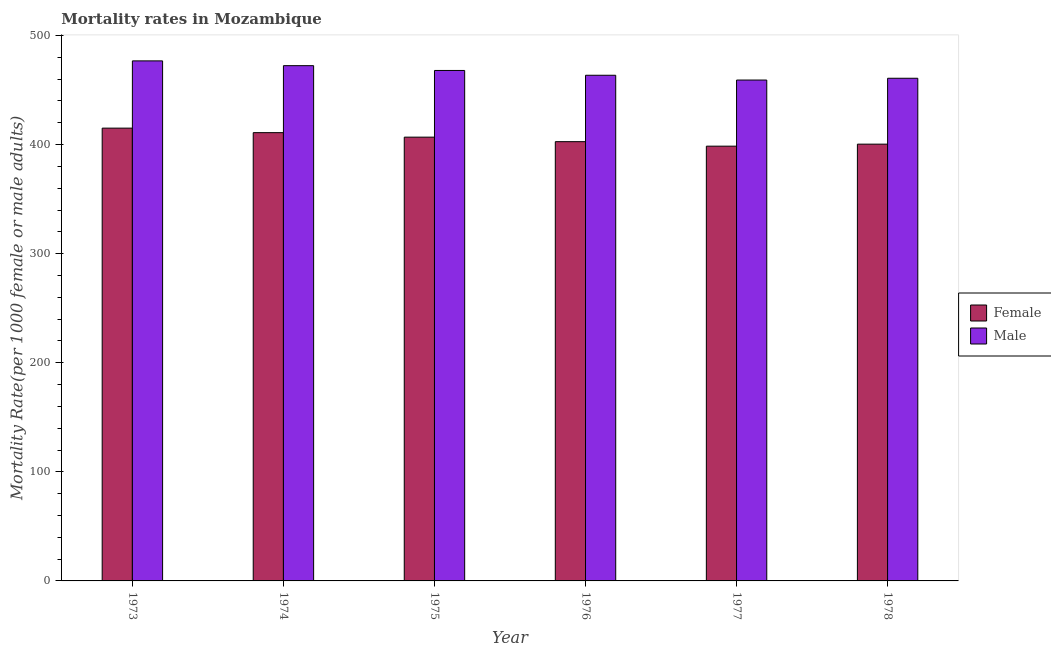How many different coloured bars are there?
Your response must be concise. 2. Are the number of bars per tick equal to the number of legend labels?
Provide a short and direct response. Yes. Are the number of bars on each tick of the X-axis equal?
Keep it short and to the point. Yes. How many bars are there on the 1st tick from the left?
Ensure brevity in your answer.  2. What is the label of the 3rd group of bars from the left?
Your answer should be very brief. 1975. In how many cases, is the number of bars for a given year not equal to the number of legend labels?
Offer a very short reply. 0. What is the female mortality rate in 1976?
Your answer should be very brief. 402.69. Across all years, what is the maximum male mortality rate?
Offer a very short reply. 476.75. Across all years, what is the minimum female mortality rate?
Give a very brief answer. 398.56. In which year was the male mortality rate maximum?
Provide a short and direct response. 1973. What is the total male mortality rate in the graph?
Provide a succinct answer. 2800.63. What is the difference between the male mortality rate in 1973 and that in 1975?
Provide a succinct answer. 8.79. What is the difference between the male mortality rate in 1977 and the female mortality rate in 1974?
Provide a short and direct response. -13.18. What is the average male mortality rate per year?
Give a very brief answer. 466.77. In the year 1973, what is the difference between the female mortality rate and male mortality rate?
Ensure brevity in your answer.  0. What is the ratio of the female mortality rate in 1974 to that in 1977?
Your answer should be very brief. 1.03. Is the male mortality rate in 1974 less than that in 1977?
Offer a very short reply. No. What is the difference between the highest and the second highest female mortality rate?
Your response must be concise. 4.13. What is the difference between the highest and the lowest female mortality rate?
Keep it short and to the point. 16.53. Is the sum of the male mortality rate in 1976 and 1978 greater than the maximum female mortality rate across all years?
Offer a very short reply. Yes. What does the 1st bar from the right in 1975 represents?
Make the answer very short. Male. How many bars are there?
Give a very brief answer. 12. Are all the bars in the graph horizontal?
Give a very brief answer. No. How many years are there in the graph?
Offer a terse response. 6. What is the difference between two consecutive major ticks on the Y-axis?
Make the answer very short. 100. Does the graph contain any zero values?
Keep it short and to the point. No. How are the legend labels stacked?
Make the answer very short. Vertical. What is the title of the graph?
Provide a short and direct response. Mortality rates in Mozambique. What is the label or title of the X-axis?
Offer a terse response. Year. What is the label or title of the Y-axis?
Make the answer very short. Mortality Rate(per 1000 female or male adults). What is the Mortality Rate(per 1000 female or male adults) in Female in 1973?
Your answer should be very brief. 415.09. What is the Mortality Rate(per 1000 female or male adults) in Male in 1973?
Give a very brief answer. 476.75. What is the Mortality Rate(per 1000 female or male adults) in Female in 1974?
Give a very brief answer. 410.96. What is the Mortality Rate(per 1000 female or male adults) in Male in 1974?
Keep it short and to the point. 472.36. What is the Mortality Rate(per 1000 female or male adults) of Female in 1975?
Your response must be concise. 406.82. What is the Mortality Rate(per 1000 female or male adults) in Male in 1975?
Make the answer very short. 467.96. What is the Mortality Rate(per 1000 female or male adults) of Female in 1976?
Ensure brevity in your answer.  402.69. What is the Mortality Rate(per 1000 female or male adults) in Male in 1976?
Offer a very short reply. 463.57. What is the Mortality Rate(per 1000 female or male adults) in Female in 1977?
Your answer should be compact. 398.56. What is the Mortality Rate(per 1000 female or male adults) in Male in 1977?
Give a very brief answer. 459.18. What is the Mortality Rate(per 1000 female or male adults) in Female in 1978?
Give a very brief answer. 400.41. What is the Mortality Rate(per 1000 female or male adults) in Male in 1978?
Offer a terse response. 460.81. Across all years, what is the maximum Mortality Rate(per 1000 female or male adults) of Female?
Ensure brevity in your answer.  415.09. Across all years, what is the maximum Mortality Rate(per 1000 female or male adults) of Male?
Offer a terse response. 476.75. Across all years, what is the minimum Mortality Rate(per 1000 female or male adults) in Female?
Provide a short and direct response. 398.56. Across all years, what is the minimum Mortality Rate(per 1000 female or male adults) in Male?
Provide a short and direct response. 459.18. What is the total Mortality Rate(per 1000 female or male adults) of Female in the graph?
Keep it short and to the point. 2434.53. What is the total Mortality Rate(per 1000 female or male adults) in Male in the graph?
Provide a short and direct response. 2800.63. What is the difference between the Mortality Rate(per 1000 female or male adults) of Female in 1973 and that in 1974?
Give a very brief answer. 4.13. What is the difference between the Mortality Rate(per 1000 female or male adults) in Male in 1973 and that in 1974?
Give a very brief answer. 4.39. What is the difference between the Mortality Rate(per 1000 female or male adults) of Female in 1973 and that in 1975?
Ensure brevity in your answer.  8.27. What is the difference between the Mortality Rate(per 1000 female or male adults) of Male in 1973 and that in 1975?
Offer a very short reply. 8.79. What is the difference between the Mortality Rate(per 1000 female or male adults) of Female in 1973 and that in 1976?
Provide a short and direct response. 12.4. What is the difference between the Mortality Rate(per 1000 female or male adults) of Male in 1973 and that in 1976?
Provide a succinct answer. 13.18. What is the difference between the Mortality Rate(per 1000 female or male adults) in Female in 1973 and that in 1977?
Offer a very short reply. 16.53. What is the difference between the Mortality Rate(per 1000 female or male adults) of Male in 1973 and that in 1977?
Offer a terse response. 17.57. What is the difference between the Mortality Rate(per 1000 female or male adults) of Female in 1973 and that in 1978?
Provide a short and direct response. 14.68. What is the difference between the Mortality Rate(per 1000 female or male adults) of Male in 1973 and that in 1978?
Offer a terse response. 15.94. What is the difference between the Mortality Rate(per 1000 female or male adults) of Female in 1974 and that in 1975?
Offer a very short reply. 4.13. What is the difference between the Mortality Rate(per 1000 female or male adults) in Male in 1974 and that in 1975?
Your answer should be very brief. 4.39. What is the difference between the Mortality Rate(per 1000 female or male adults) in Female in 1974 and that in 1976?
Provide a succinct answer. 8.27. What is the difference between the Mortality Rate(per 1000 female or male adults) in Male in 1974 and that in 1976?
Your response must be concise. 8.79. What is the difference between the Mortality Rate(per 1000 female or male adults) of Female in 1974 and that in 1977?
Offer a very short reply. 12.4. What is the difference between the Mortality Rate(per 1000 female or male adults) in Male in 1974 and that in 1977?
Keep it short and to the point. 13.18. What is the difference between the Mortality Rate(per 1000 female or male adults) in Female in 1974 and that in 1978?
Ensure brevity in your answer.  10.54. What is the difference between the Mortality Rate(per 1000 female or male adults) of Male in 1974 and that in 1978?
Offer a very short reply. 11.54. What is the difference between the Mortality Rate(per 1000 female or male adults) in Female in 1975 and that in 1976?
Keep it short and to the point. 4.13. What is the difference between the Mortality Rate(per 1000 female or male adults) in Male in 1975 and that in 1976?
Your answer should be very brief. 4.39. What is the difference between the Mortality Rate(per 1000 female or male adults) of Female in 1975 and that in 1977?
Your response must be concise. 8.27. What is the difference between the Mortality Rate(per 1000 female or male adults) of Male in 1975 and that in 1977?
Ensure brevity in your answer.  8.79. What is the difference between the Mortality Rate(per 1000 female or male adults) in Female in 1975 and that in 1978?
Make the answer very short. 6.41. What is the difference between the Mortality Rate(per 1000 female or male adults) of Male in 1975 and that in 1978?
Provide a succinct answer. 7.15. What is the difference between the Mortality Rate(per 1000 female or male adults) of Female in 1976 and that in 1977?
Give a very brief answer. 4.13. What is the difference between the Mortality Rate(per 1000 female or male adults) of Male in 1976 and that in 1977?
Offer a very short reply. 4.39. What is the difference between the Mortality Rate(per 1000 female or male adults) of Female in 1976 and that in 1978?
Offer a very short reply. 2.28. What is the difference between the Mortality Rate(per 1000 female or male adults) of Male in 1976 and that in 1978?
Make the answer very short. 2.76. What is the difference between the Mortality Rate(per 1000 female or male adults) of Female in 1977 and that in 1978?
Keep it short and to the point. -1.85. What is the difference between the Mortality Rate(per 1000 female or male adults) in Male in 1977 and that in 1978?
Offer a very short reply. -1.63. What is the difference between the Mortality Rate(per 1000 female or male adults) of Female in 1973 and the Mortality Rate(per 1000 female or male adults) of Male in 1974?
Offer a very short reply. -57.27. What is the difference between the Mortality Rate(per 1000 female or male adults) of Female in 1973 and the Mortality Rate(per 1000 female or male adults) of Male in 1975?
Offer a terse response. -52.87. What is the difference between the Mortality Rate(per 1000 female or male adults) of Female in 1973 and the Mortality Rate(per 1000 female or male adults) of Male in 1976?
Offer a terse response. -48.48. What is the difference between the Mortality Rate(per 1000 female or male adults) of Female in 1973 and the Mortality Rate(per 1000 female or male adults) of Male in 1977?
Your answer should be very brief. -44.09. What is the difference between the Mortality Rate(per 1000 female or male adults) of Female in 1973 and the Mortality Rate(per 1000 female or male adults) of Male in 1978?
Give a very brief answer. -45.72. What is the difference between the Mortality Rate(per 1000 female or male adults) in Female in 1974 and the Mortality Rate(per 1000 female or male adults) in Male in 1975?
Make the answer very short. -57.01. What is the difference between the Mortality Rate(per 1000 female or male adults) in Female in 1974 and the Mortality Rate(per 1000 female or male adults) in Male in 1976?
Provide a short and direct response. -52.61. What is the difference between the Mortality Rate(per 1000 female or male adults) in Female in 1974 and the Mortality Rate(per 1000 female or male adults) in Male in 1977?
Your response must be concise. -48.22. What is the difference between the Mortality Rate(per 1000 female or male adults) of Female in 1974 and the Mortality Rate(per 1000 female or male adults) of Male in 1978?
Your response must be concise. -49.85. What is the difference between the Mortality Rate(per 1000 female or male adults) of Female in 1975 and the Mortality Rate(per 1000 female or male adults) of Male in 1976?
Ensure brevity in your answer.  -56.75. What is the difference between the Mortality Rate(per 1000 female or male adults) in Female in 1975 and the Mortality Rate(per 1000 female or male adults) in Male in 1977?
Your answer should be very brief. -52.35. What is the difference between the Mortality Rate(per 1000 female or male adults) in Female in 1975 and the Mortality Rate(per 1000 female or male adults) in Male in 1978?
Make the answer very short. -53.99. What is the difference between the Mortality Rate(per 1000 female or male adults) in Female in 1976 and the Mortality Rate(per 1000 female or male adults) in Male in 1977?
Give a very brief answer. -56.49. What is the difference between the Mortality Rate(per 1000 female or male adults) of Female in 1976 and the Mortality Rate(per 1000 female or male adults) of Male in 1978?
Provide a succinct answer. -58.12. What is the difference between the Mortality Rate(per 1000 female or male adults) in Female in 1977 and the Mortality Rate(per 1000 female or male adults) in Male in 1978?
Ensure brevity in your answer.  -62.26. What is the average Mortality Rate(per 1000 female or male adults) in Female per year?
Give a very brief answer. 405.76. What is the average Mortality Rate(per 1000 female or male adults) in Male per year?
Give a very brief answer. 466.77. In the year 1973, what is the difference between the Mortality Rate(per 1000 female or male adults) of Female and Mortality Rate(per 1000 female or male adults) of Male?
Your answer should be compact. -61.66. In the year 1974, what is the difference between the Mortality Rate(per 1000 female or male adults) of Female and Mortality Rate(per 1000 female or male adults) of Male?
Give a very brief answer. -61.4. In the year 1975, what is the difference between the Mortality Rate(per 1000 female or male adults) of Female and Mortality Rate(per 1000 female or male adults) of Male?
Ensure brevity in your answer.  -61.14. In the year 1976, what is the difference between the Mortality Rate(per 1000 female or male adults) of Female and Mortality Rate(per 1000 female or male adults) of Male?
Your response must be concise. -60.88. In the year 1977, what is the difference between the Mortality Rate(per 1000 female or male adults) in Female and Mortality Rate(per 1000 female or male adults) in Male?
Provide a succinct answer. -60.62. In the year 1978, what is the difference between the Mortality Rate(per 1000 female or male adults) of Female and Mortality Rate(per 1000 female or male adults) of Male?
Your response must be concise. -60.4. What is the ratio of the Mortality Rate(per 1000 female or male adults) in Female in 1973 to that in 1974?
Offer a very short reply. 1.01. What is the ratio of the Mortality Rate(per 1000 female or male adults) of Male in 1973 to that in 1974?
Your answer should be very brief. 1.01. What is the ratio of the Mortality Rate(per 1000 female or male adults) of Female in 1973 to that in 1975?
Keep it short and to the point. 1.02. What is the ratio of the Mortality Rate(per 1000 female or male adults) of Male in 1973 to that in 1975?
Make the answer very short. 1.02. What is the ratio of the Mortality Rate(per 1000 female or male adults) in Female in 1973 to that in 1976?
Offer a terse response. 1.03. What is the ratio of the Mortality Rate(per 1000 female or male adults) of Male in 1973 to that in 1976?
Offer a very short reply. 1.03. What is the ratio of the Mortality Rate(per 1000 female or male adults) in Female in 1973 to that in 1977?
Give a very brief answer. 1.04. What is the ratio of the Mortality Rate(per 1000 female or male adults) in Male in 1973 to that in 1977?
Your response must be concise. 1.04. What is the ratio of the Mortality Rate(per 1000 female or male adults) of Female in 1973 to that in 1978?
Keep it short and to the point. 1.04. What is the ratio of the Mortality Rate(per 1000 female or male adults) in Male in 1973 to that in 1978?
Keep it short and to the point. 1.03. What is the ratio of the Mortality Rate(per 1000 female or male adults) in Female in 1974 to that in 1975?
Offer a very short reply. 1.01. What is the ratio of the Mortality Rate(per 1000 female or male adults) of Male in 1974 to that in 1975?
Your answer should be very brief. 1.01. What is the ratio of the Mortality Rate(per 1000 female or male adults) in Female in 1974 to that in 1976?
Make the answer very short. 1.02. What is the ratio of the Mortality Rate(per 1000 female or male adults) in Female in 1974 to that in 1977?
Your answer should be very brief. 1.03. What is the ratio of the Mortality Rate(per 1000 female or male adults) of Male in 1974 to that in 1977?
Your response must be concise. 1.03. What is the ratio of the Mortality Rate(per 1000 female or male adults) in Female in 1974 to that in 1978?
Provide a succinct answer. 1.03. What is the ratio of the Mortality Rate(per 1000 female or male adults) in Male in 1974 to that in 1978?
Your response must be concise. 1.03. What is the ratio of the Mortality Rate(per 1000 female or male adults) of Female in 1975 to that in 1976?
Your answer should be very brief. 1.01. What is the ratio of the Mortality Rate(per 1000 female or male adults) of Male in 1975 to that in 1976?
Your answer should be very brief. 1.01. What is the ratio of the Mortality Rate(per 1000 female or male adults) of Female in 1975 to that in 1977?
Offer a very short reply. 1.02. What is the ratio of the Mortality Rate(per 1000 female or male adults) in Male in 1975 to that in 1977?
Provide a short and direct response. 1.02. What is the ratio of the Mortality Rate(per 1000 female or male adults) in Female in 1975 to that in 1978?
Your answer should be very brief. 1.02. What is the ratio of the Mortality Rate(per 1000 female or male adults) in Male in 1975 to that in 1978?
Make the answer very short. 1.02. What is the ratio of the Mortality Rate(per 1000 female or male adults) in Female in 1976 to that in 1977?
Give a very brief answer. 1.01. What is the ratio of the Mortality Rate(per 1000 female or male adults) of Male in 1976 to that in 1977?
Give a very brief answer. 1.01. What is the ratio of the Mortality Rate(per 1000 female or male adults) of Female in 1976 to that in 1978?
Your answer should be compact. 1.01. What is the ratio of the Mortality Rate(per 1000 female or male adults) of Female in 1977 to that in 1978?
Your response must be concise. 1. What is the ratio of the Mortality Rate(per 1000 female or male adults) of Male in 1977 to that in 1978?
Your answer should be compact. 1. What is the difference between the highest and the second highest Mortality Rate(per 1000 female or male adults) in Female?
Keep it short and to the point. 4.13. What is the difference between the highest and the second highest Mortality Rate(per 1000 female or male adults) of Male?
Your answer should be compact. 4.39. What is the difference between the highest and the lowest Mortality Rate(per 1000 female or male adults) of Female?
Make the answer very short. 16.53. What is the difference between the highest and the lowest Mortality Rate(per 1000 female or male adults) in Male?
Your response must be concise. 17.57. 